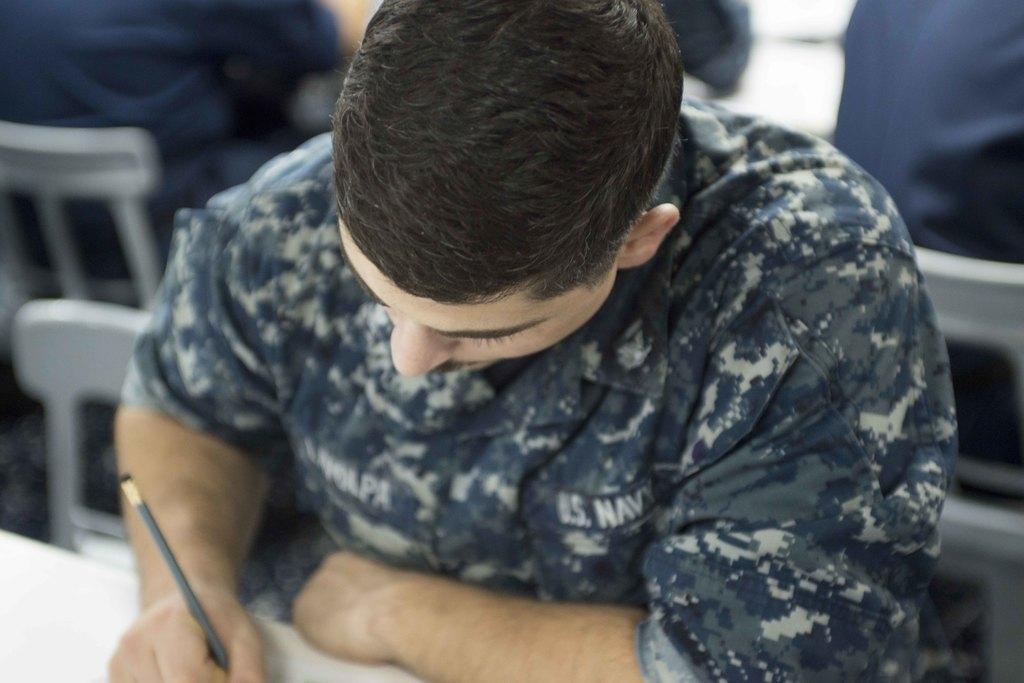In one or two sentences, can you explain what this image depicts? In this picture we can see a person holding a pencil and writing. There are a few people sitting on a chair in the background. 